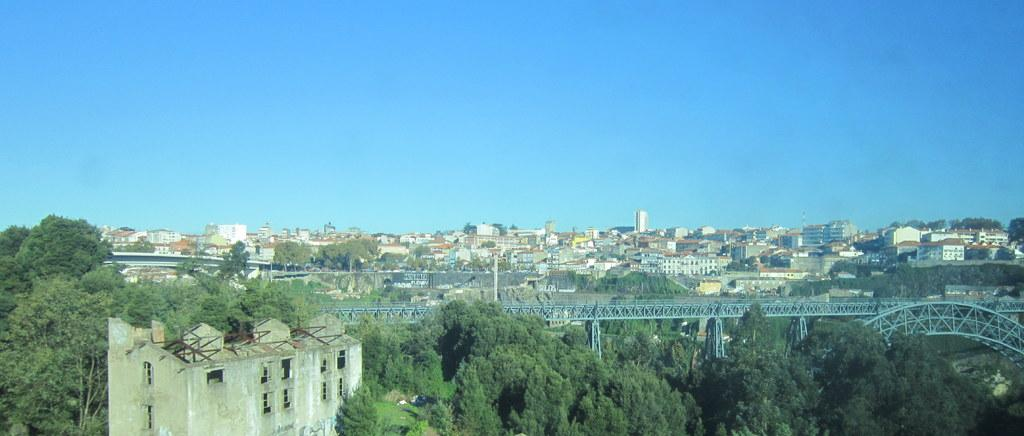What type of structure can be seen in the image? There is a bridge in the image. What else is present in the image besides the bridge? There are buildings and trees in the image. What can be seen in the background of the image? The sky is visible in the background of the image. How many brothers are standing on the bridge in the image? There are no brothers present in the image; it only features a bridge, buildings, trees, and the sky. What type of rail can be seen on the bridge in the image? There is no rail visible on the bridge in the image. 